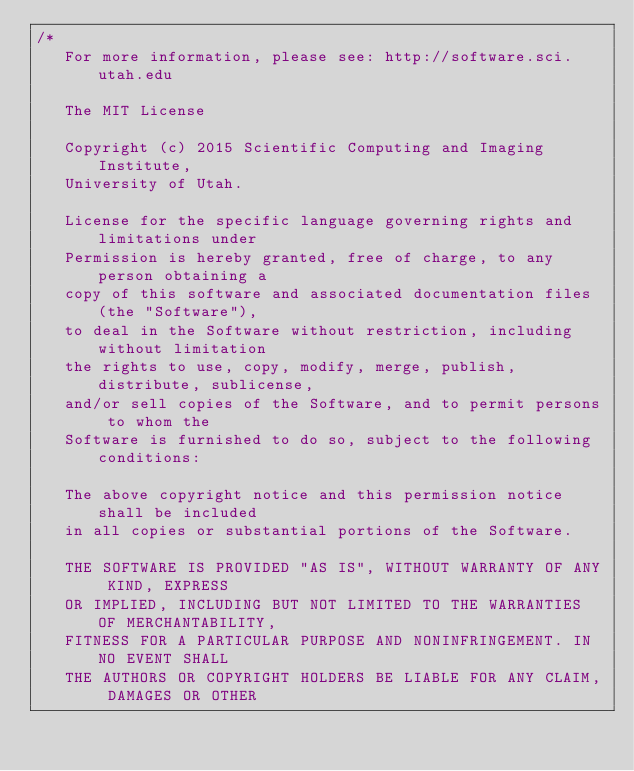<code> <loc_0><loc_0><loc_500><loc_500><_C++_>/*
   For more information, please see: http://software.sci.utah.edu

   The MIT License

   Copyright (c) 2015 Scientific Computing and Imaging Institute,
   University of Utah.

   License for the specific language governing rights and limitations under
   Permission is hereby granted, free of charge, to any person obtaining a
   copy of this software and associated documentation files (the "Software"),
   to deal in the Software without restriction, including without limitation
   the rights to use, copy, modify, merge, publish, distribute, sublicense,
   and/or sell copies of the Software, and to permit persons to whom the
   Software is furnished to do so, subject to the following conditions:

   The above copyright notice and this permission notice shall be included
   in all copies or substantial portions of the Software.

   THE SOFTWARE IS PROVIDED "AS IS", WITHOUT WARRANTY OF ANY KIND, EXPRESS
   OR IMPLIED, INCLUDING BUT NOT LIMITED TO THE WARRANTIES OF MERCHANTABILITY,
   FITNESS FOR A PARTICULAR PURPOSE AND NONINFRINGEMENT. IN NO EVENT SHALL
   THE AUTHORS OR COPYRIGHT HOLDERS BE LIABLE FOR ANY CLAIM, DAMAGES OR OTHER</code> 